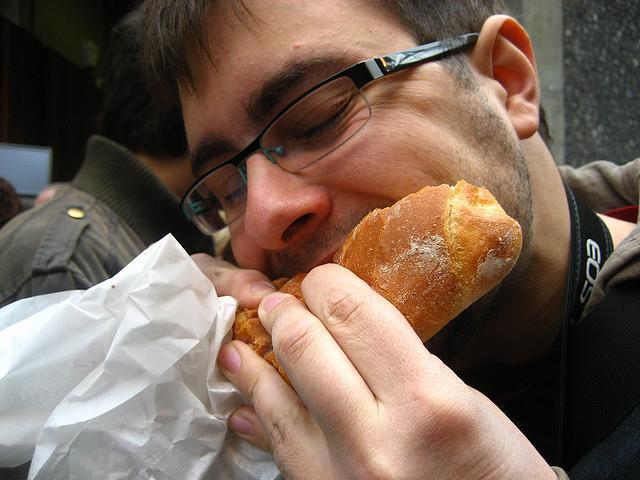How many people can be seen?
Give a very brief answer. 2. 